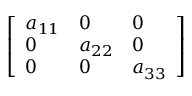Convert formula to latex. <formula><loc_0><loc_0><loc_500><loc_500>\left [ \begin{array} { l l l } { a _ { 1 1 } } & { 0 } & { 0 } \\ { 0 } & { a _ { 2 2 } } & { 0 } \\ { 0 } & { 0 } & { a _ { 3 3 } } \end{array} \right ]</formula> 